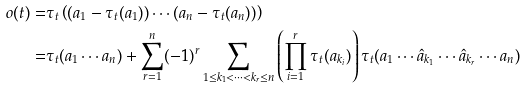Convert formula to latex. <formula><loc_0><loc_0><loc_500><loc_500>o ( t ) = & \tau _ { t } \left ( ( a _ { 1 } - \tau _ { t } ( a _ { 1 } ) ) \cdots ( a _ { n } - \tau _ { t } ( a _ { n } ) ) \right ) \\ = & \tau _ { t } ( a _ { 1 } \cdots a _ { n } ) + \sum _ { r = 1 } ^ { n } ( - 1 ) ^ { r } \sum _ { 1 \leq k _ { 1 } < \dots < k _ { r } \leq n } \left ( \prod _ { i = 1 } ^ { r } \tau _ { t } ( a _ { k _ { i } } ) \right ) \tau _ { t } ( a _ { 1 } \cdots \hat { a } _ { k _ { 1 } } \cdots \hat { a } _ { k _ { r } } \cdots a _ { n } )</formula> 